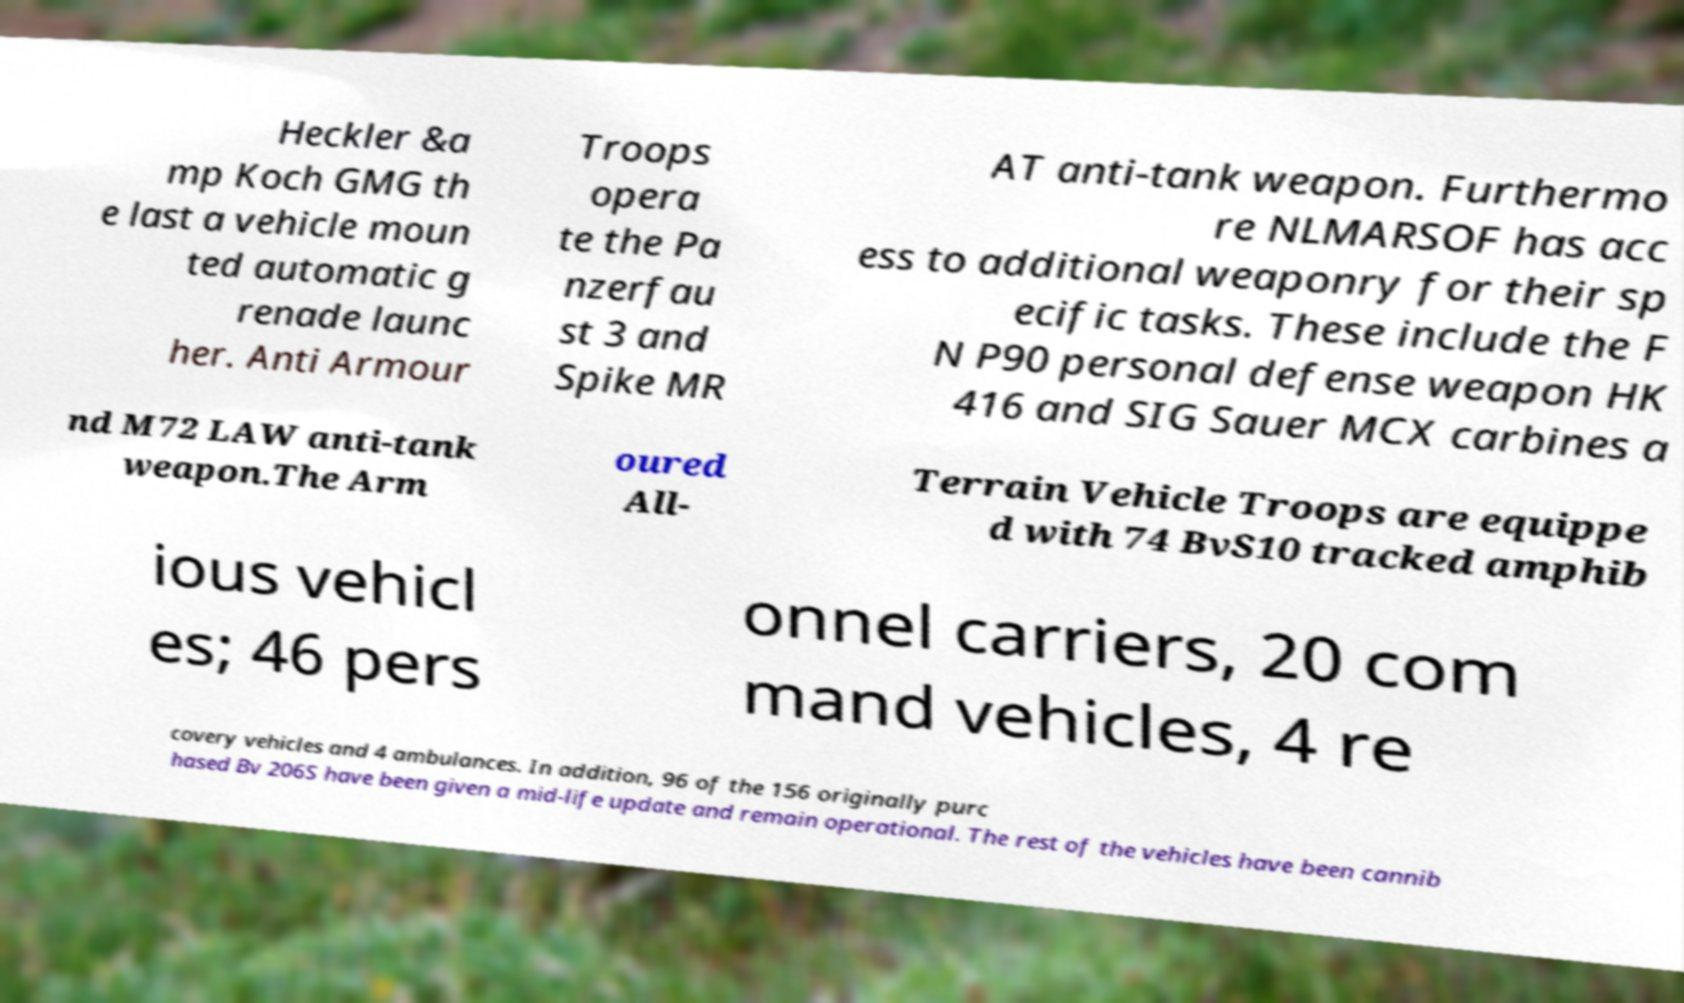Could you extract and type out the text from this image? Heckler &a mp Koch GMG th e last a vehicle moun ted automatic g renade launc her. Anti Armour Troops opera te the Pa nzerfau st 3 and Spike MR AT anti-tank weapon. Furthermo re NLMARSOF has acc ess to additional weaponry for their sp ecific tasks. These include the F N P90 personal defense weapon HK 416 and SIG Sauer MCX carbines a nd M72 LAW anti-tank weapon.The Arm oured All- Terrain Vehicle Troops are equippe d with 74 BvS10 tracked amphib ious vehicl es; 46 pers onnel carriers, 20 com mand vehicles, 4 re covery vehicles and 4 ambulances. In addition, 96 of the 156 originally purc hased Bv 206S have been given a mid-life update and remain operational. The rest of the vehicles have been cannib 